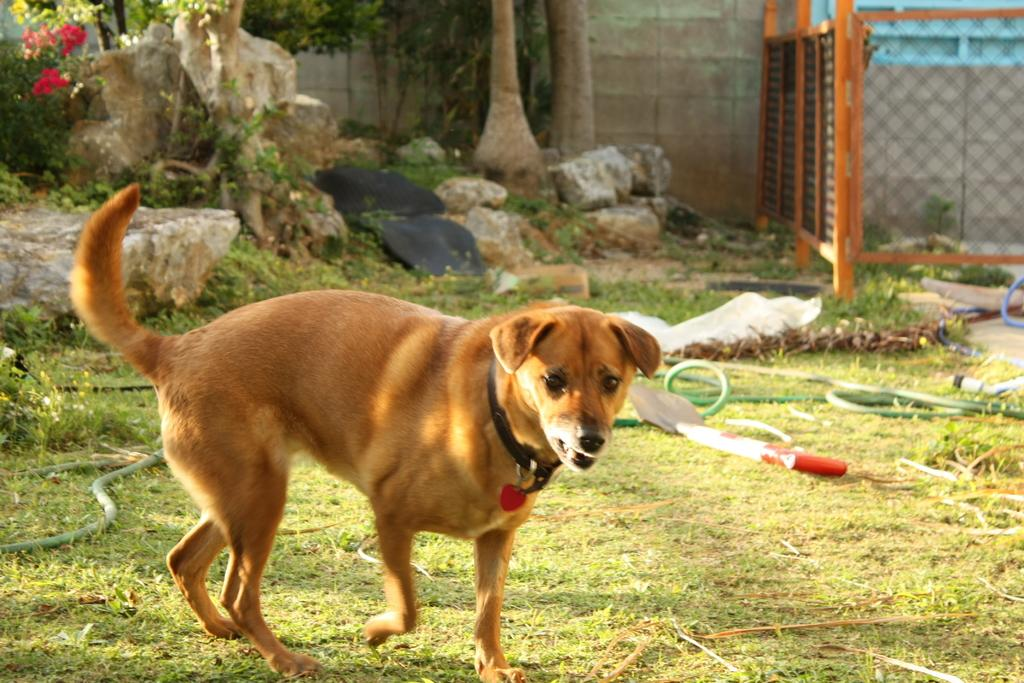What type of animal is present in the image? There is a brown dog with a collar in the image. What is the ground surface like in the image? There is grass on the ground in the image. What object can be seen on the ground in the image? There is a pipe on the ground in the image. What type of natural features are visible in the background of the image? There are rocks and trees in the background of the image. What type of structure is present in the image? There is a wooden wall in the image. What type of doctor is treating the dog in the image? There is no doctor present in the image, and the dog is not being treated. 